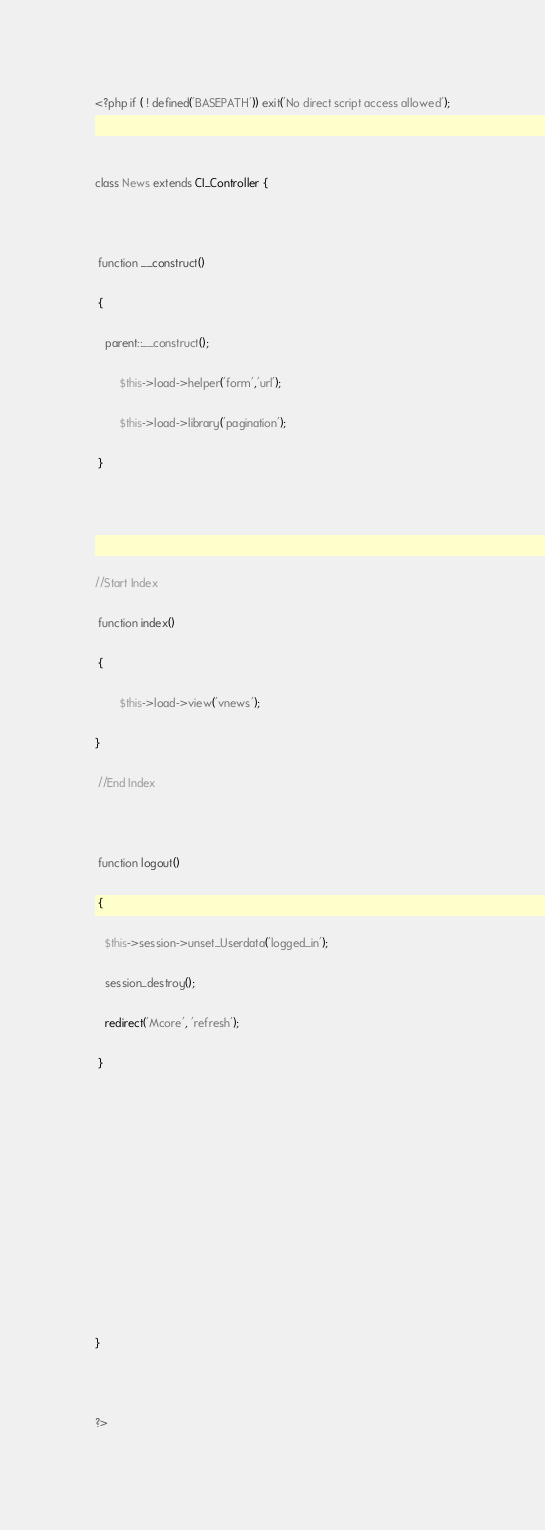<code> <loc_0><loc_0><loc_500><loc_500><_PHP_><?php if ( ! defined('BASEPATH')) exit('No direct script access allowed');

class News extends CI_Controller {

 function __construct()
 {
   parent::__construct();
        $this->load->helper('form','url');
        $this->load->library('pagination');
 }


//Start Index
 function index()
 {
        $this->load->view('vnews');
}
 //End Index
 
 function logout()
 {
   $this->session->unset_Userdata('logged_in');
   session_destroy();
   redirect('Mcore', 'refresh');
 }






}

?></code> 